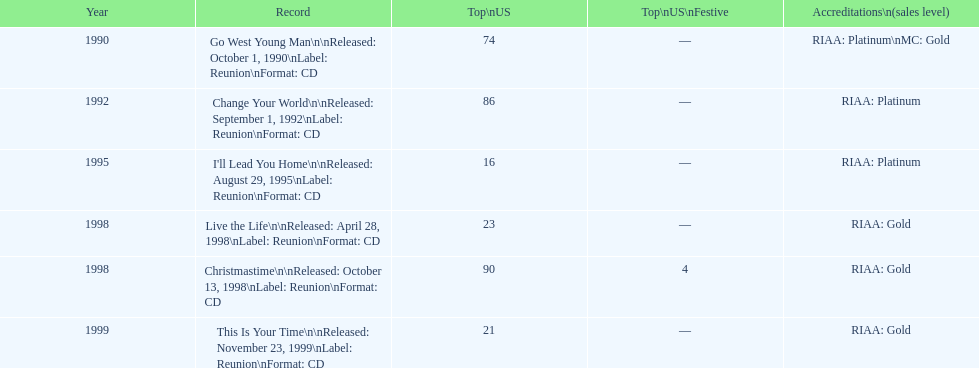What year is the oldest one on the list? 1990. 